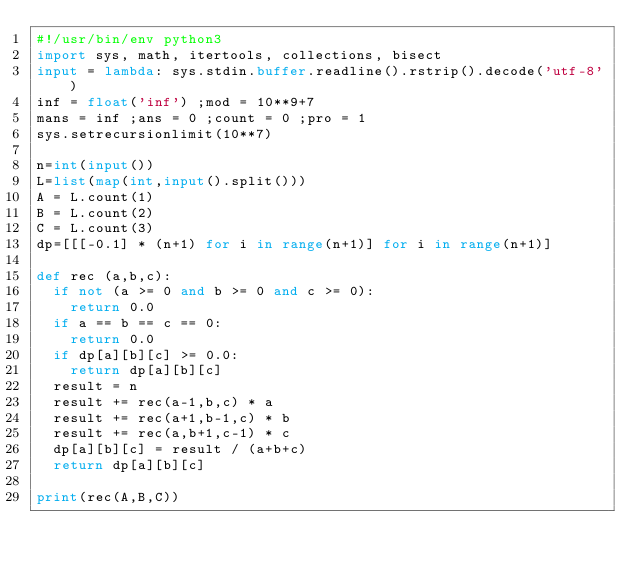<code> <loc_0><loc_0><loc_500><loc_500><_Python_>#!/usr/bin/env python3
import sys, math, itertools, collections, bisect
input = lambda: sys.stdin.buffer.readline().rstrip().decode('utf-8')
inf = float('inf') ;mod = 10**9+7
mans = inf ;ans = 0 ;count = 0 ;pro = 1
sys.setrecursionlimit(10**7)

n=int(input())
L=list(map(int,input().split()))
A = L.count(1)
B = L.count(2)
C = L.count(3)
dp=[[[-0.1] * (n+1) for i in range(n+1)] for i in range(n+1)]

def rec (a,b,c):
  if not (a >= 0 and b >= 0 and c >= 0):
    return 0.0
  if a == b == c == 0:
    return 0.0
  if dp[a][b][c] >= 0.0:
    return dp[a][b][c]
  result = n
  result += rec(a-1,b,c) * a
  result += rec(a+1,b-1,c) * b
  result += rec(a,b+1,c-1) * c
  dp[a][b][c] = result / (a+b+c)
  return dp[a][b][c]

print(rec(A,B,C))</code> 